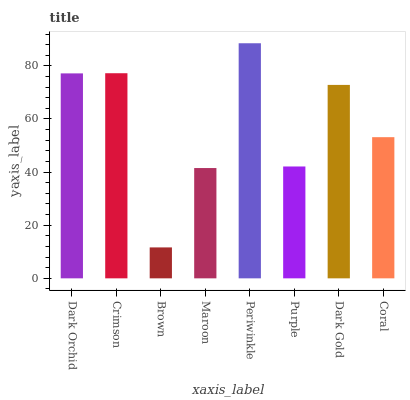Is Crimson the minimum?
Answer yes or no. No. Is Crimson the maximum?
Answer yes or no. No. Is Crimson greater than Dark Orchid?
Answer yes or no. Yes. Is Dark Orchid less than Crimson?
Answer yes or no. Yes. Is Dark Orchid greater than Crimson?
Answer yes or no. No. Is Crimson less than Dark Orchid?
Answer yes or no. No. Is Dark Gold the high median?
Answer yes or no. Yes. Is Coral the low median?
Answer yes or no. Yes. Is Maroon the high median?
Answer yes or no. No. Is Periwinkle the low median?
Answer yes or no. No. 